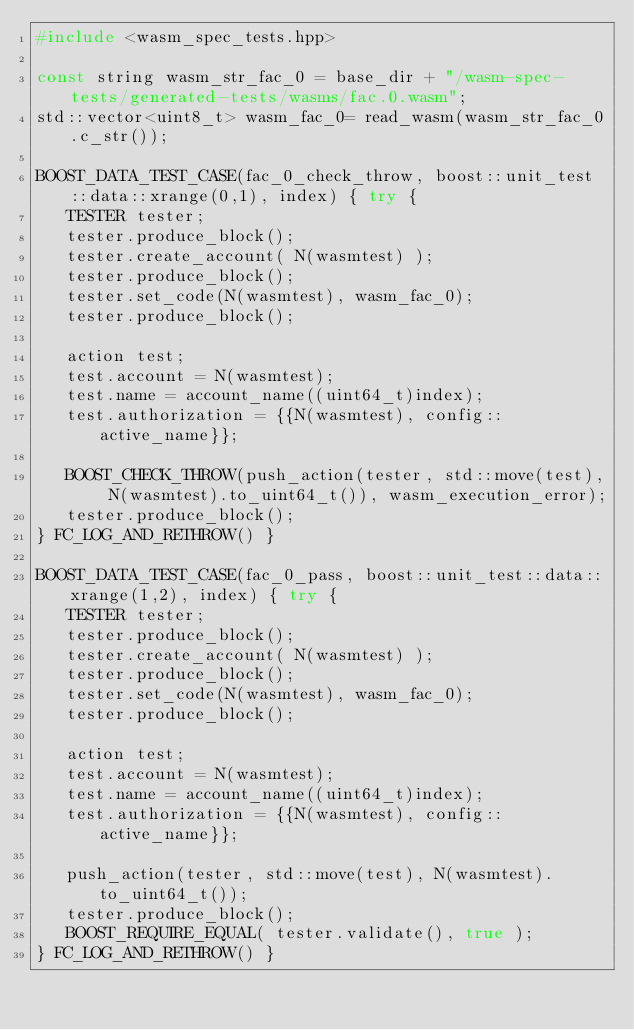<code> <loc_0><loc_0><loc_500><loc_500><_C++_>#include <wasm_spec_tests.hpp>

const string wasm_str_fac_0 = base_dir + "/wasm-spec-tests/generated-tests/wasms/fac.0.wasm";
std::vector<uint8_t> wasm_fac_0= read_wasm(wasm_str_fac_0.c_str());

BOOST_DATA_TEST_CASE(fac_0_check_throw, boost::unit_test::data::xrange(0,1), index) { try {
   TESTER tester;
   tester.produce_block();
   tester.create_account( N(wasmtest) );
   tester.produce_block();
   tester.set_code(N(wasmtest), wasm_fac_0);
   tester.produce_block();

   action test;
   test.account = N(wasmtest);
   test.name = account_name((uint64_t)index);
   test.authorization = {{N(wasmtest), config::active_name}};

   BOOST_CHECK_THROW(push_action(tester, std::move(test), N(wasmtest).to_uint64_t()), wasm_execution_error);
   tester.produce_block();
} FC_LOG_AND_RETHROW() }

BOOST_DATA_TEST_CASE(fac_0_pass, boost::unit_test::data::xrange(1,2), index) { try {
   TESTER tester;
   tester.produce_block();
   tester.create_account( N(wasmtest) );
   tester.produce_block();
   tester.set_code(N(wasmtest), wasm_fac_0);
   tester.produce_block();

   action test;
   test.account = N(wasmtest);
   test.name = account_name((uint64_t)index);
   test.authorization = {{N(wasmtest), config::active_name}};

   push_action(tester, std::move(test), N(wasmtest).to_uint64_t());
   tester.produce_block();
   BOOST_REQUIRE_EQUAL( tester.validate(), true );
} FC_LOG_AND_RETHROW() }

</code> 